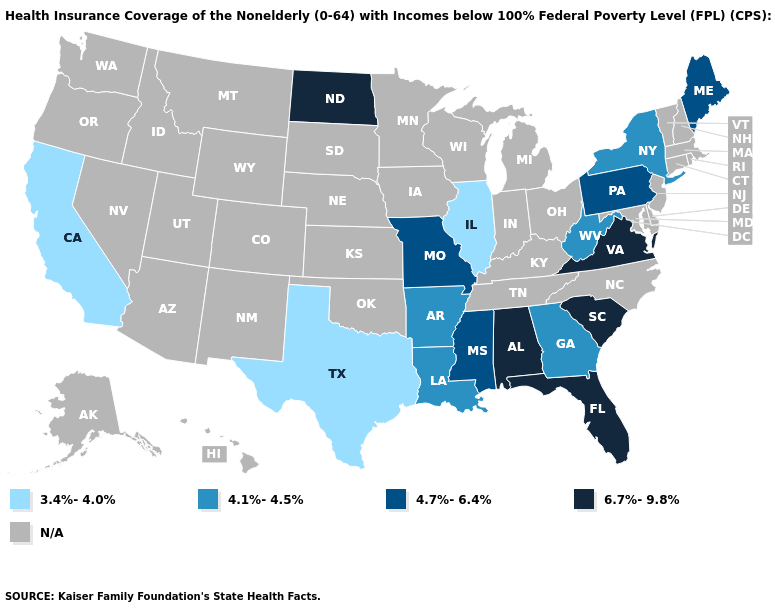Name the states that have a value in the range 3.4%-4.0%?
Concise answer only. California, Illinois, Texas. Name the states that have a value in the range 6.7%-9.8%?
Give a very brief answer. Alabama, Florida, North Dakota, South Carolina, Virginia. Name the states that have a value in the range 4.1%-4.5%?
Keep it brief. Arkansas, Georgia, Louisiana, New York, West Virginia. How many symbols are there in the legend?
Quick response, please. 5. Which states have the lowest value in the MidWest?
Keep it brief. Illinois. Name the states that have a value in the range 6.7%-9.8%?
Write a very short answer. Alabama, Florida, North Dakota, South Carolina, Virginia. Among the states that border Mississippi , which have the lowest value?
Give a very brief answer. Arkansas, Louisiana. Name the states that have a value in the range 4.1%-4.5%?
Answer briefly. Arkansas, Georgia, Louisiana, New York, West Virginia. Does the first symbol in the legend represent the smallest category?
Keep it brief. Yes. Which states have the highest value in the USA?
Keep it brief. Alabama, Florida, North Dakota, South Carolina, Virginia. What is the highest value in the MidWest ?
Quick response, please. 6.7%-9.8%. How many symbols are there in the legend?
Give a very brief answer. 5. How many symbols are there in the legend?
Quick response, please. 5. Name the states that have a value in the range 3.4%-4.0%?
Quick response, please. California, Illinois, Texas. 